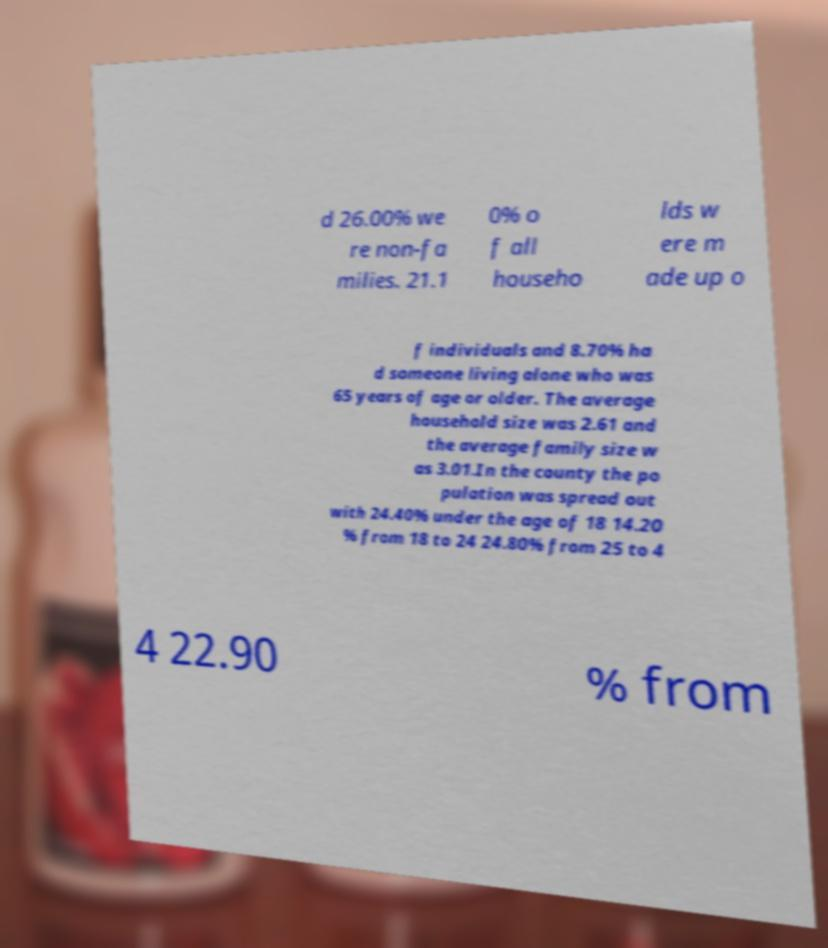For documentation purposes, I need the text within this image transcribed. Could you provide that? d 26.00% we re non-fa milies. 21.1 0% o f all househo lds w ere m ade up o f individuals and 8.70% ha d someone living alone who was 65 years of age or older. The average household size was 2.61 and the average family size w as 3.01.In the county the po pulation was spread out with 24.40% under the age of 18 14.20 % from 18 to 24 24.80% from 25 to 4 4 22.90 % from 